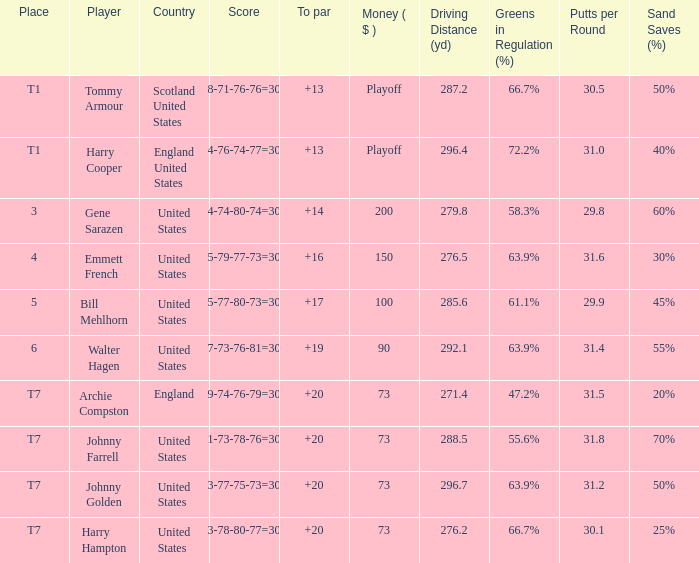What is the ranking when Archie Compston is the player and the money is $73? T7. 